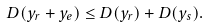Convert formula to latex. <formula><loc_0><loc_0><loc_500><loc_500>D ( y _ { r } + y _ { e } ) \leq D ( y _ { r } ) + D ( y _ { s } ) .</formula> 